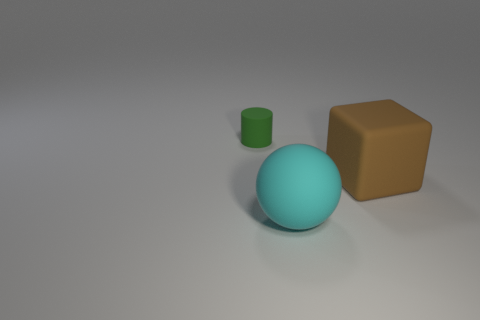There is a big object in front of the large brown matte block; what is its color?
Provide a succinct answer. Cyan. What number of green things are either cylinders or matte cubes?
Offer a terse response. 1. The big block is what color?
Your answer should be compact. Brown. Is there any other thing that has the same material as the large cyan object?
Offer a very short reply. Yes. Is the number of things that are behind the brown matte object less than the number of cyan balls to the right of the cyan sphere?
Keep it short and to the point. No. There is a thing that is both right of the small green rubber thing and to the left of the large brown rubber cube; what shape is it?
Keep it short and to the point. Sphere. How many other brown things are the same shape as the big brown rubber thing?
Provide a short and direct response. 0. There is a cyan ball that is made of the same material as the cube; what size is it?
Your answer should be compact. Large. What number of blue rubber objects have the same size as the cyan rubber object?
Ensure brevity in your answer.  0. There is a matte thing right of the large rubber object that is in front of the large brown rubber block; what color is it?
Provide a succinct answer. Brown. 